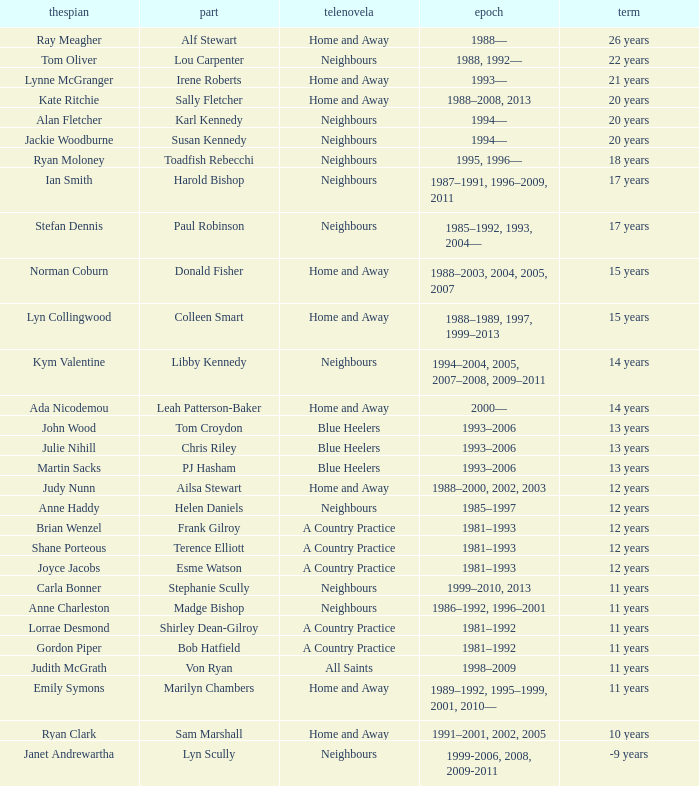Which performer had a 20-year stint on home and away? Kate Ritchie. 